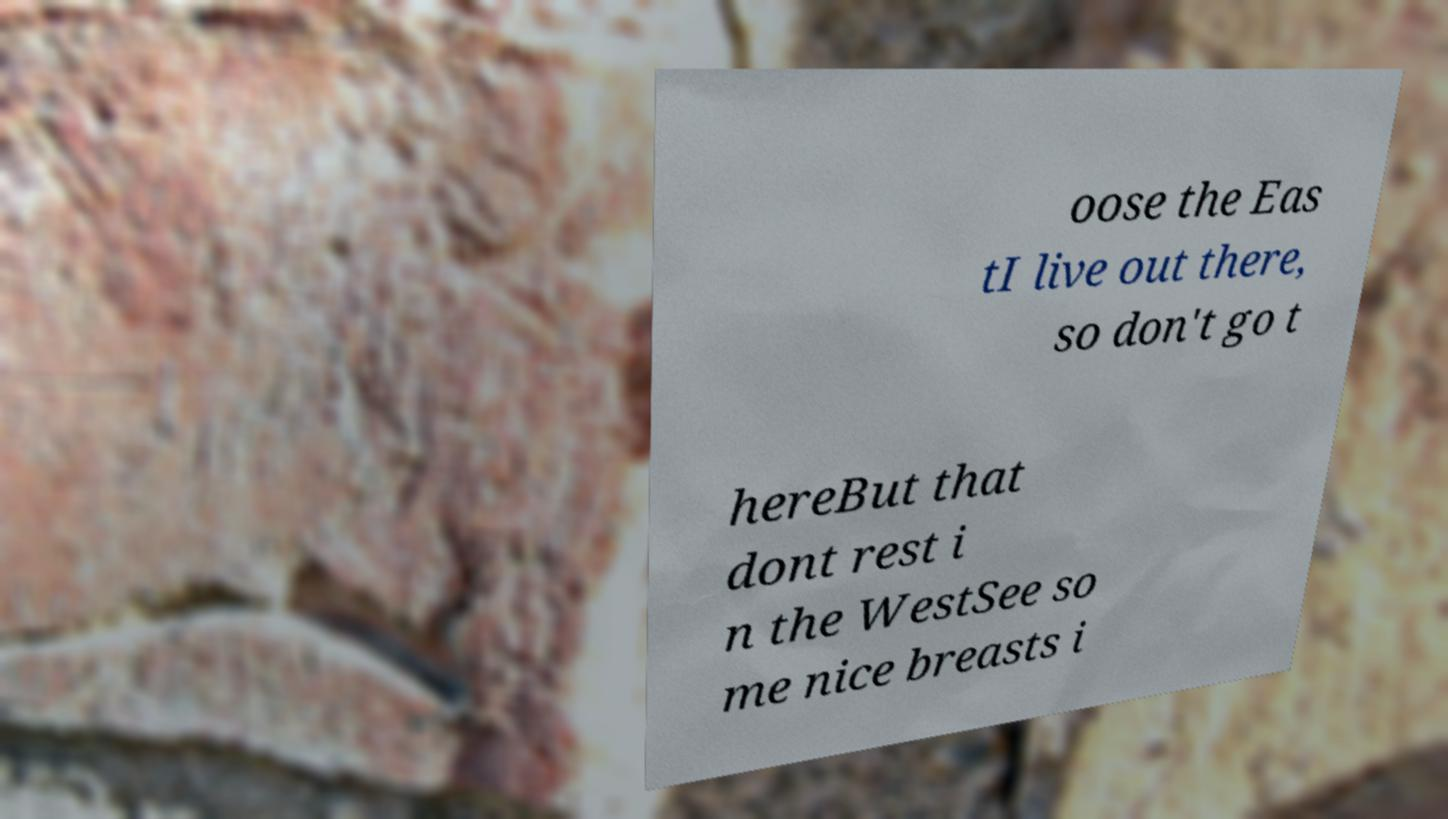There's text embedded in this image that I need extracted. Can you transcribe it verbatim? oose the Eas tI live out there, so don't go t hereBut that dont rest i n the WestSee so me nice breasts i 